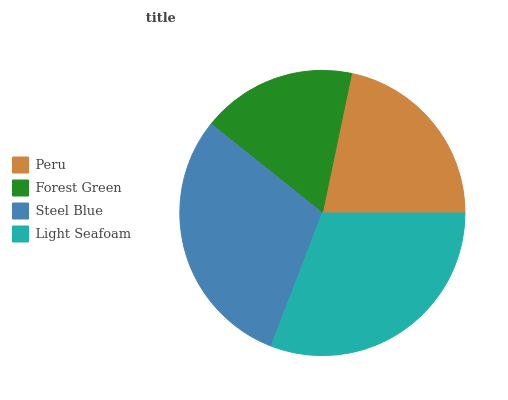Is Forest Green the minimum?
Answer yes or no. Yes. Is Light Seafoam the maximum?
Answer yes or no. Yes. Is Steel Blue the minimum?
Answer yes or no. No. Is Steel Blue the maximum?
Answer yes or no. No. Is Steel Blue greater than Forest Green?
Answer yes or no. Yes. Is Forest Green less than Steel Blue?
Answer yes or no. Yes. Is Forest Green greater than Steel Blue?
Answer yes or no. No. Is Steel Blue less than Forest Green?
Answer yes or no. No. Is Steel Blue the high median?
Answer yes or no. Yes. Is Peru the low median?
Answer yes or no. Yes. Is Light Seafoam the high median?
Answer yes or no. No. Is Steel Blue the low median?
Answer yes or no. No. 